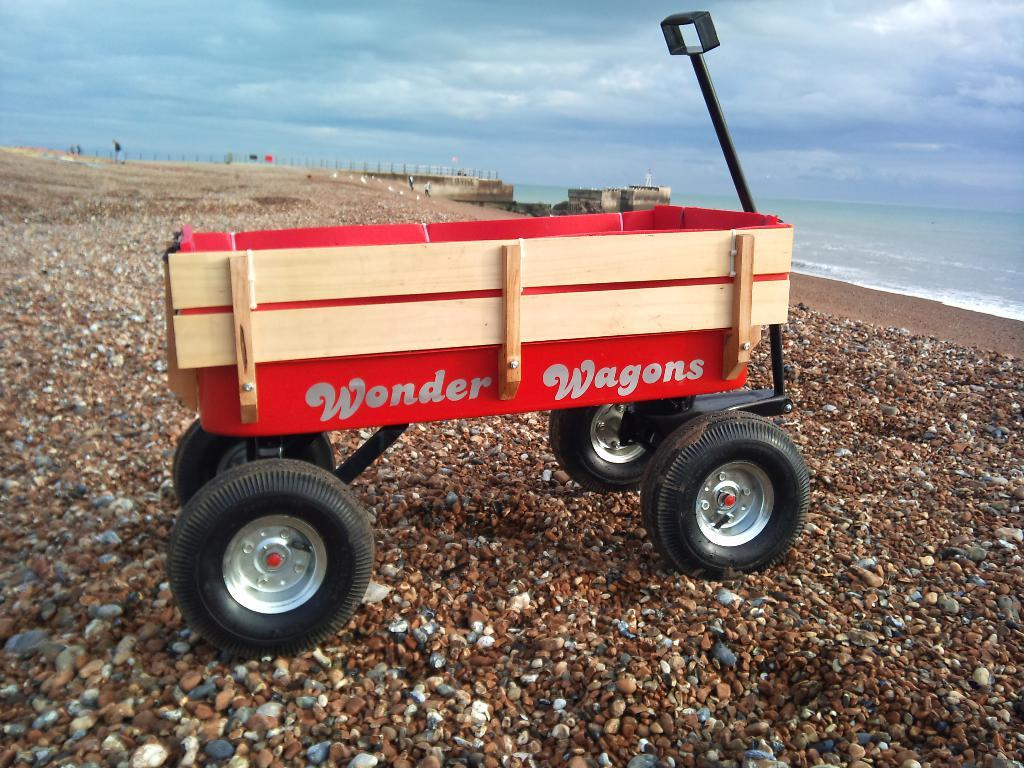What is the main object in the image? There is a beach wagon in the image. Where is the beach wagon located? The beach wagon is on a path. What can be seen in the background of the image? There is a sea visible in the image. How would you describe the weather based on the image? The sky is cloudy in the image. How many eggs are being measured in the jail in the image? There is no reference to eggs, measuring, or a jail in the image. 